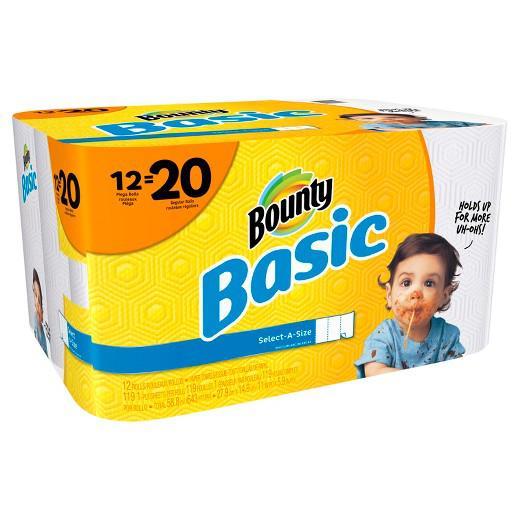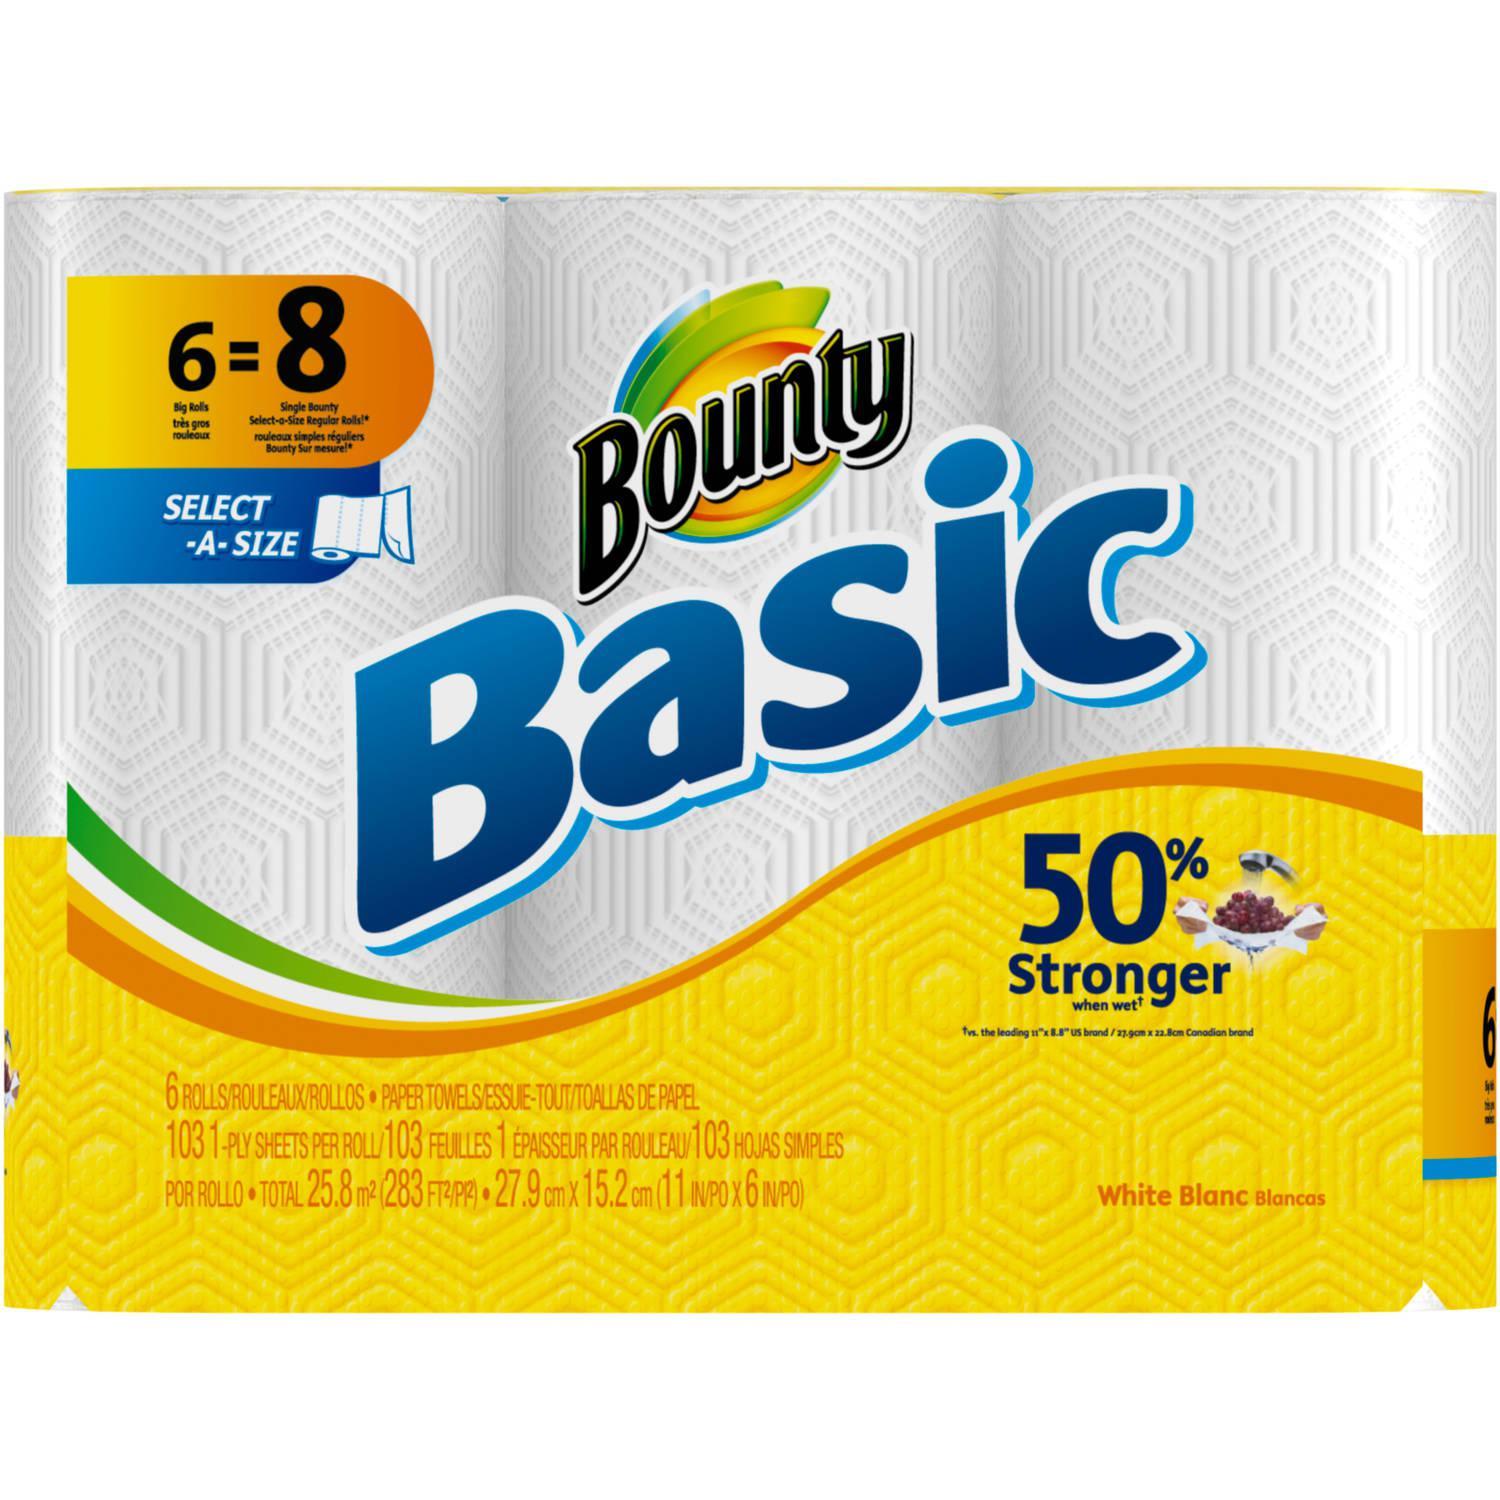The first image is the image on the left, the second image is the image on the right. Given the left and right images, does the statement "The left image contains a multipack of paper towel rolls with a baby's face on the front, and the right image contains packaging with the same color scheme as the left." hold true? Answer yes or no. Yes. The first image is the image on the left, the second image is the image on the right. Given the left and right images, does the statement "There is a child with a messy face." hold true? Answer yes or no. Yes. 